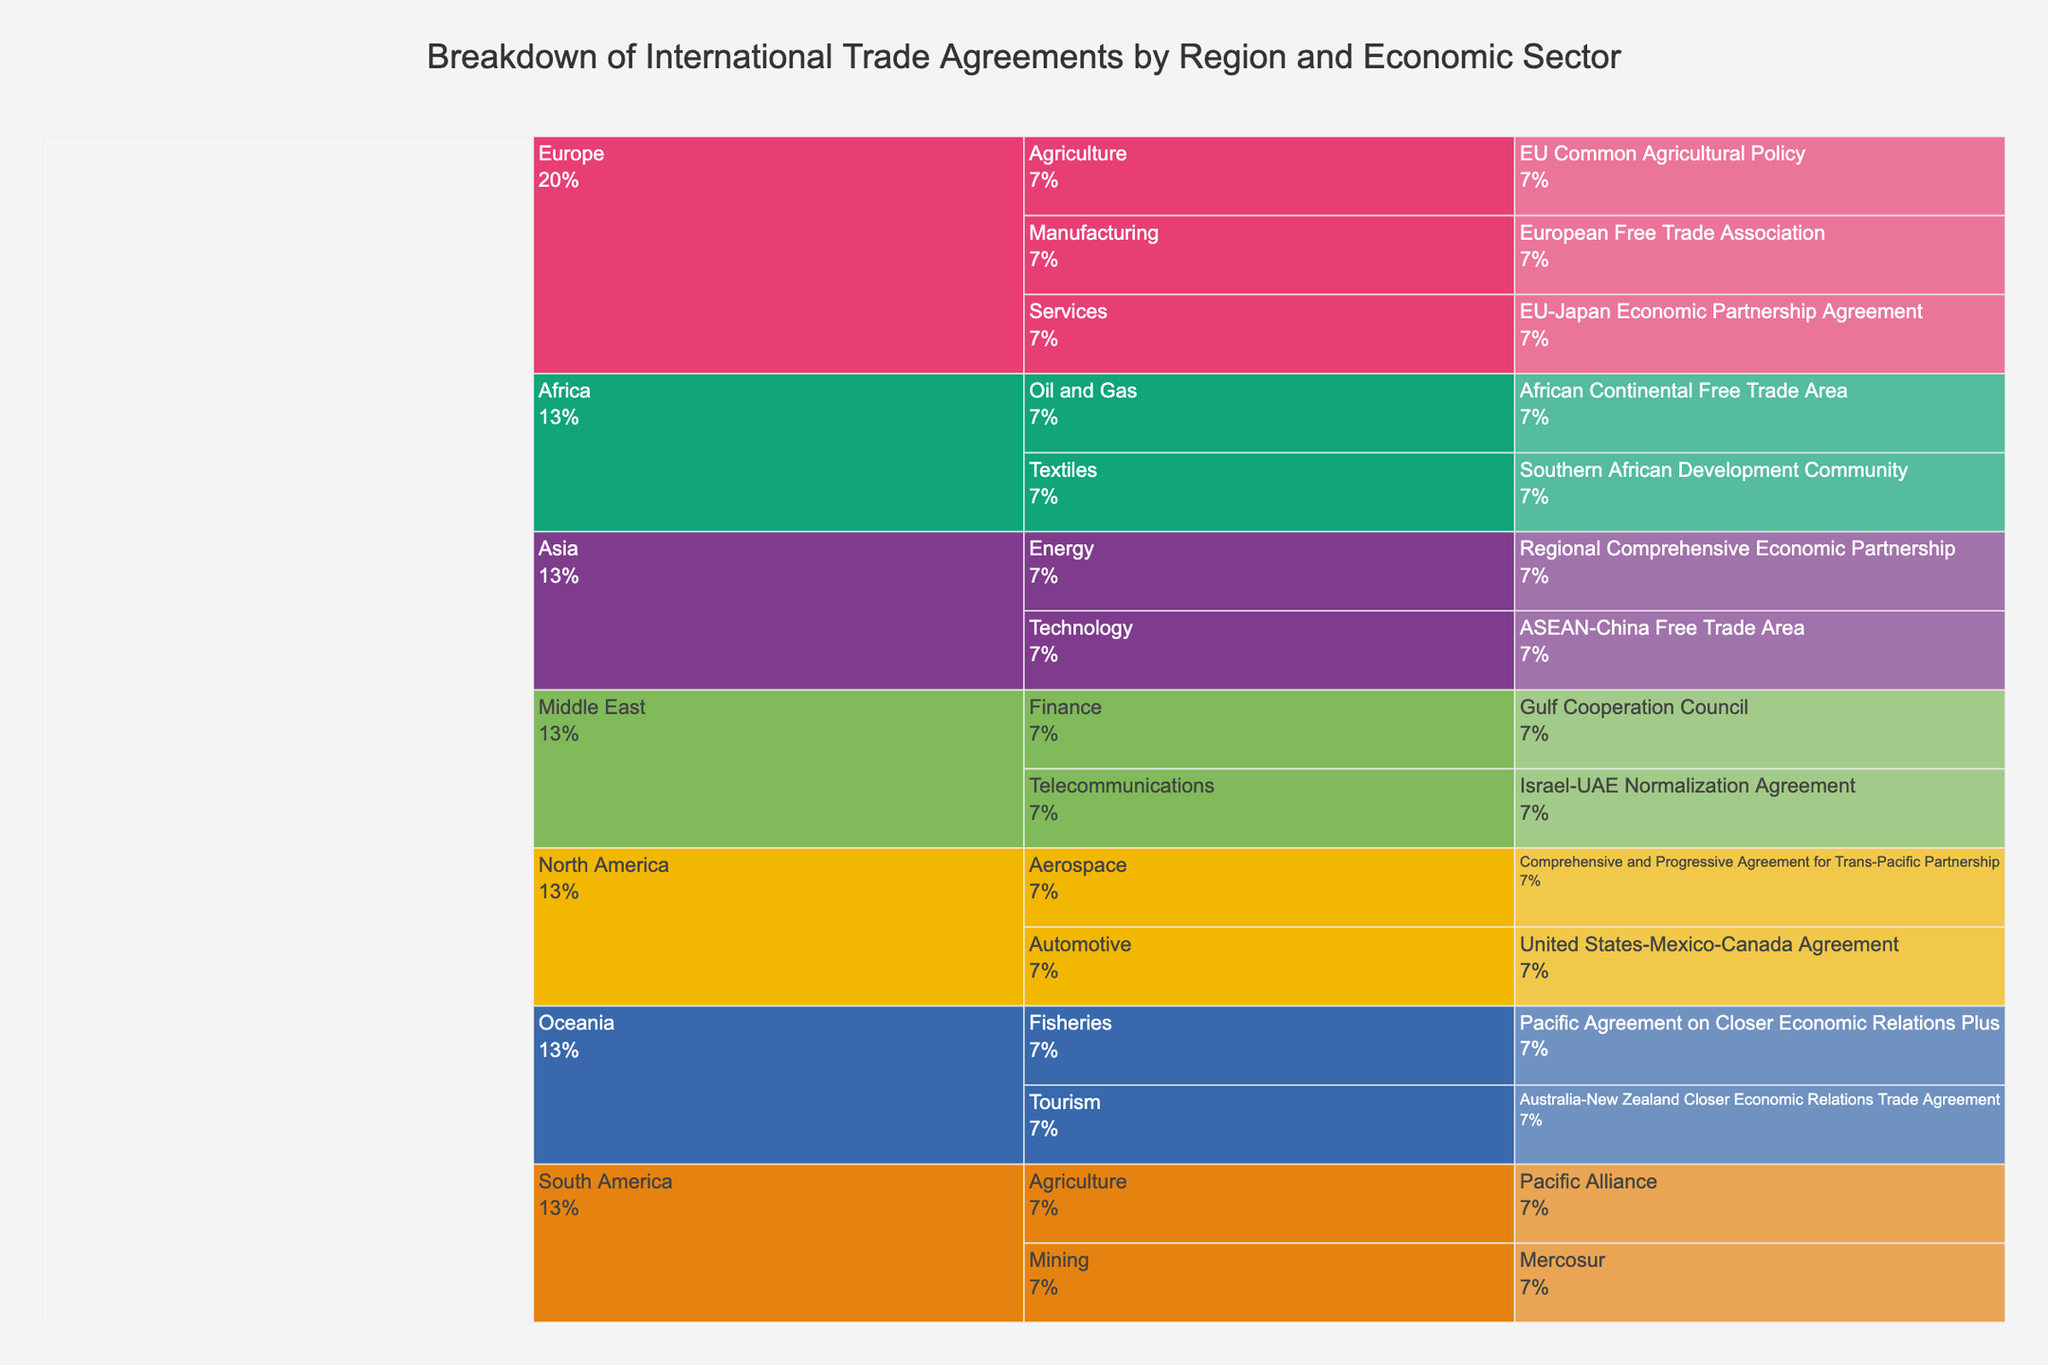What is the title of the figure? The title of the figure is located at the top of the chart. By reading this text, you can identify the title.
Answer: Breakdown of International Trade Agreements by Region and Economic Sector Which region has the most economic sectors represented? To answer this, count the number of economic sectors listed for each region. Compare the counts to find the region with the highest number.
Answer: Europe How many trade agreements are represented in the Agriculture sector across all regions? Identify the Agriculture sector under each region and count the number of trade agreements listed. Sum these counts to get the total.
Answer: 2 Which economic sector has agreements in the most regions? Examine each economic sector to see in which regions it has trade agreements. Count the number of regions for each sector and identify the one with the highest count.
Answer: Agriculture What is the trade agreement between Australia and New Zealand? Locate the region Oceania, then identify the economic sector under it, and find the trade agreement listed.
Answer: Australia-New Zealand Closer Economic Relations Trade Agreement Which regions have an agreement in the Technology sector? Look for the Technology sector within the chart and identify the regions it falls under.
Answer: Asia Compare the number of trade agreements in the Americas (North and South America) to those in Europe. Which has more? Count the total agreements listed under North and South America, then count the agreements under Europe, and compare the two totals.
Answer: Americas What percentage of the total entries does the Europe region account for? Count the total entries in the entire chart and the entries under Europe. Divide Europe's count by the total and multiply by 100 to get the percentage. For example, if there are 3 entries under Europe out of 15 total entries, the percentage is (3/15)*100 = 20%.
Answer: Requires counting entries to provide percentage 